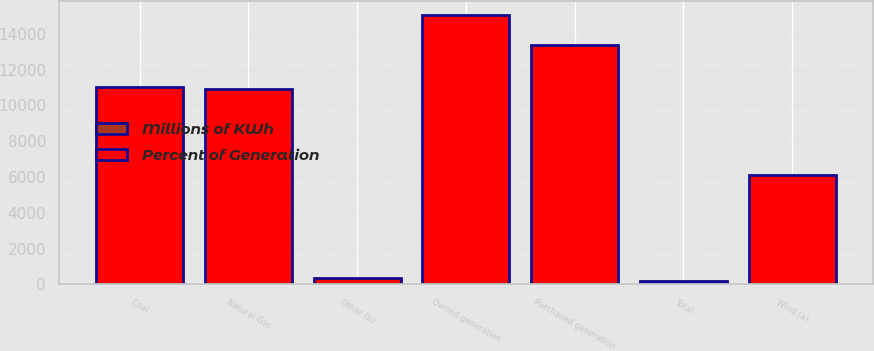Convert chart to OTSL. <chart><loc_0><loc_0><loc_500><loc_500><stacked_bar_chart><ecel><fcel>Coal<fcel>Natural Gas<fcel>Wind (a)<fcel>Other (b)<fcel>Total<fcel>Owned generation<fcel>Purchased generation<nl><fcel>Percent of Generation<fcel>10990<fcel>10909<fcel>6120<fcel>347<fcel>100<fcel>15015<fcel>13351<nl><fcel>Millions of KWh<fcel>39<fcel>38<fcel>22<fcel>1<fcel>100<fcel>53<fcel>47<nl></chart> 